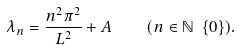<formula> <loc_0><loc_0><loc_500><loc_500>\lambda _ { n } = { \frac { n ^ { 2 } \pi ^ { 2 } } { L ^ { 2 } } } + A \quad ( n \in \mathbb { N } \ \{ 0 \} ) .</formula> 